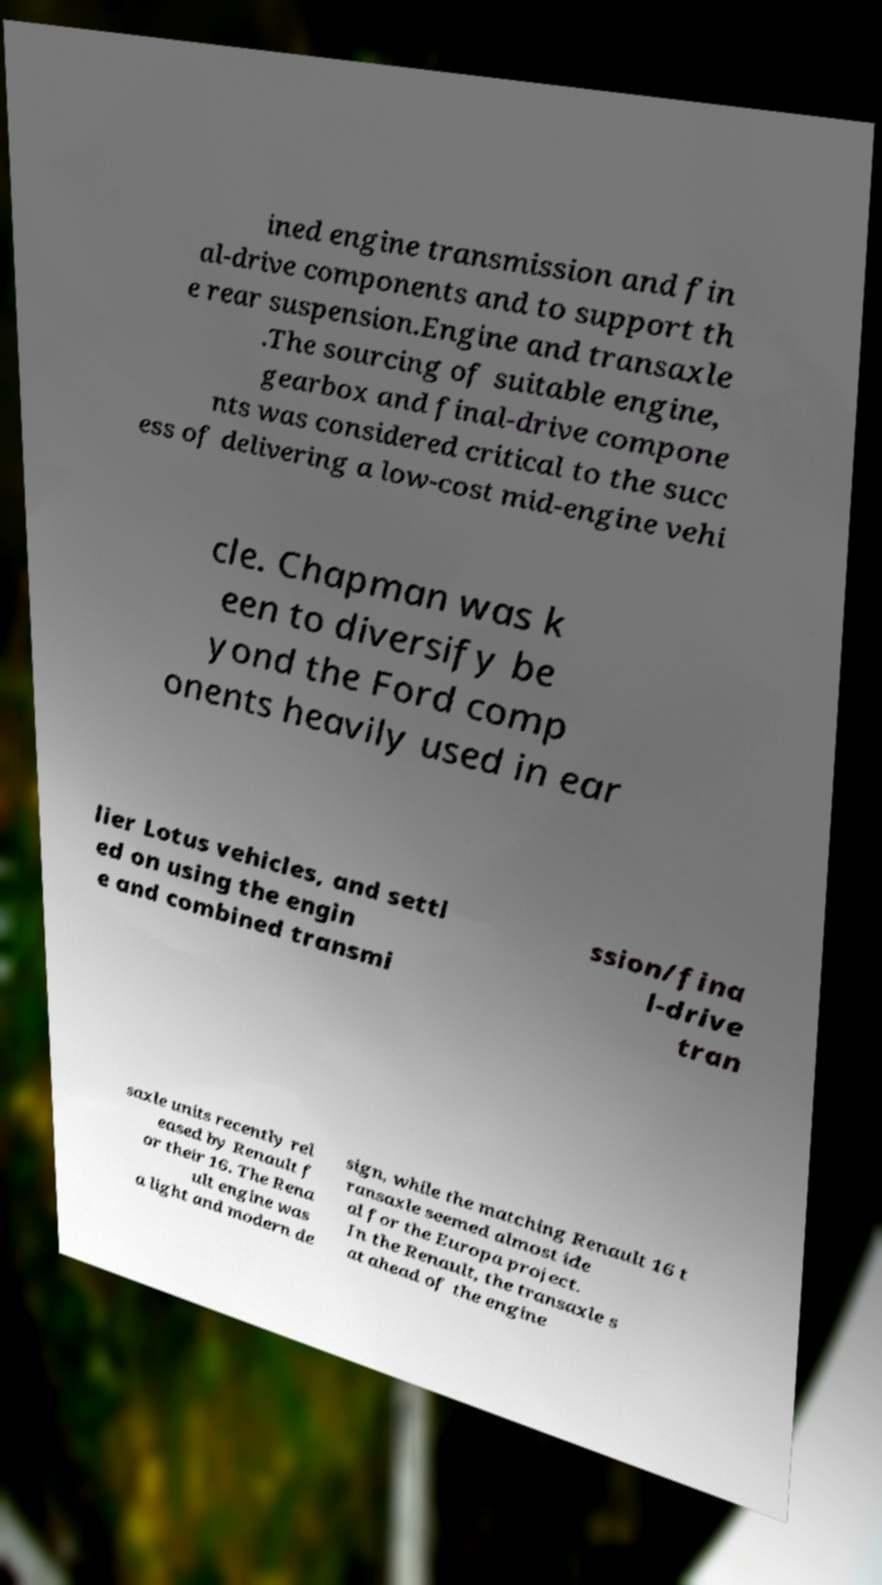What messages or text are displayed in this image? I need them in a readable, typed format. ined engine transmission and fin al-drive components and to support th e rear suspension.Engine and transaxle .The sourcing of suitable engine, gearbox and final-drive compone nts was considered critical to the succ ess of delivering a low-cost mid-engine vehi cle. Chapman was k een to diversify be yond the Ford comp onents heavily used in ear lier Lotus vehicles, and settl ed on using the engin e and combined transmi ssion/fina l-drive tran saxle units recently rel eased by Renault f or their 16. The Rena ult engine was a light and modern de sign, while the matching Renault 16 t ransaxle seemed almost ide al for the Europa project. In the Renault, the transaxle s at ahead of the engine 